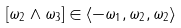Convert formula to latex. <formula><loc_0><loc_0><loc_500><loc_500>[ \omega _ { 2 } \wedge \omega _ { 3 } ] \in \langle - \omega _ { 1 } , \omega _ { 2 } , \omega _ { 2 } \rangle</formula> 